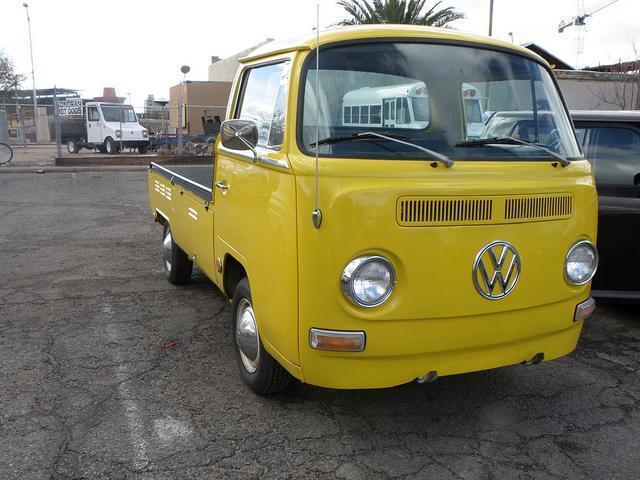How many trucks are in the photo?
Give a very brief answer. 2. How many people are wearing a helmet in this picture?
Give a very brief answer. 0. 